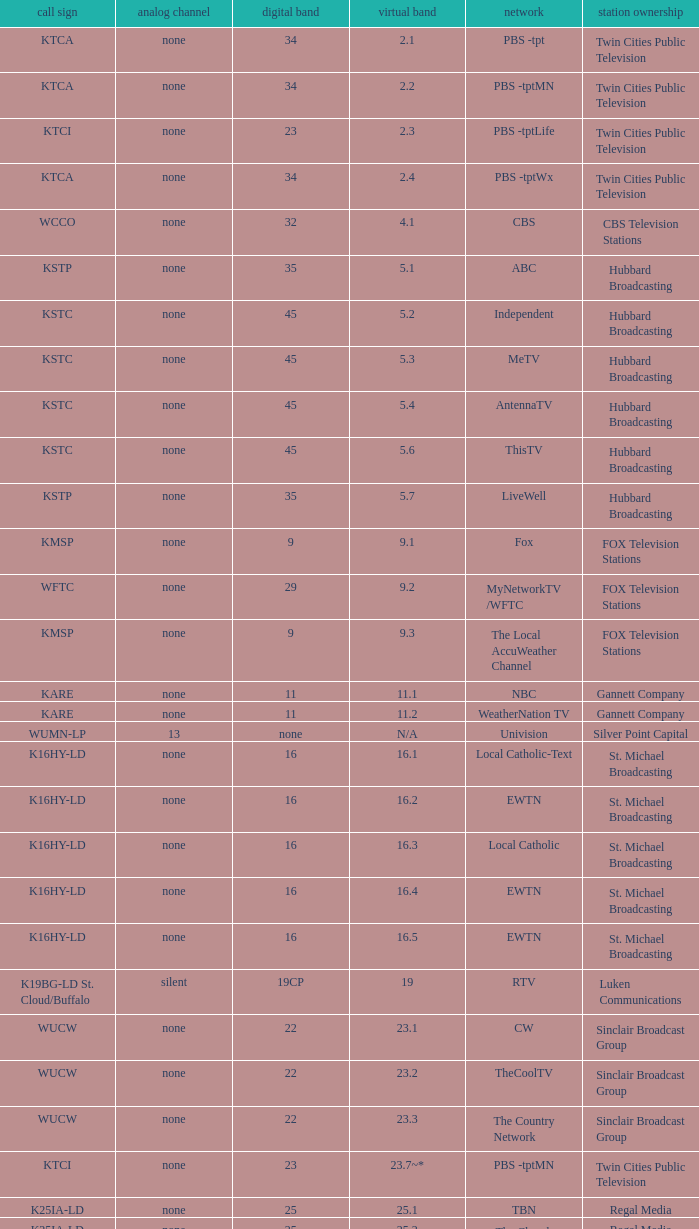Digital channel of 32 belongs to what analog channel? None. 